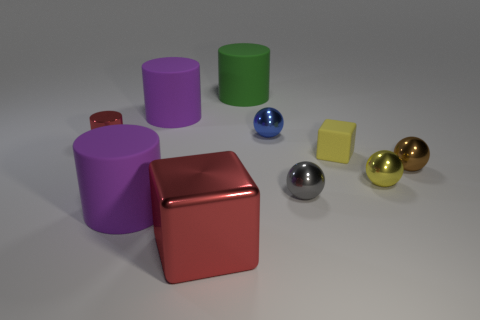Is there a large green thing that has the same material as the small cylinder?
Your answer should be very brief. No. Is the material of the large thing that is on the right side of the large metallic cube the same as the small yellow cube?
Offer a very short reply. Yes. Are there more tiny rubber blocks left of the tiny brown ball than small red shiny things on the right side of the small gray shiny sphere?
Provide a succinct answer. Yes. What color is the metal cylinder that is the same size as the blue thing?
Offer a very short reply. Red. Are there any big metallic objects of the same color as the small cylinder?
Provide a short and direct response. Yes. There is a tiny shiny object that is to the left of the blue shiny object; is it the same color as the block that is on the left side of the small block?
Provide a succinct answer. Yes. What material is the small object that is to the left of the green rubber thing?
Provide a succinct answer. Metal. There is another large thing that is the same material as the blue object; what color is it?
Offer a very short reply. Red. What number of metallic things are the same size as the red shiny cylinder?
Your answer should be compact. 4. There is a block in front of the yellow metal sphere; does it have the same size as the large green matte thing?
Keep it short and to the point. Yes. 